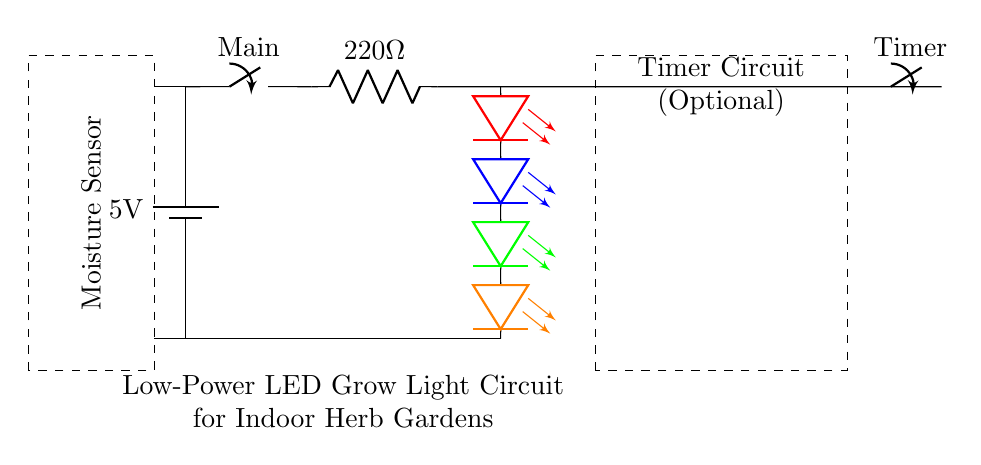What is the main power supply voltage in this circuit? The circuit uses a battery labeled with a voltage of 5V, indicating the main power supply for the circuit. This detail is crucial as it determines the voltage available for subsequent components.
Answer: 5V What is the role of the 220 Ohm resistor? The 220 Ohm resistor is a current limiting resistor, designed to restrict the flow of current to the LED array to prevent damage. By limiting the current, it ensures that the voltage drop is appropriate for the LEDs to operate safely.
Answer: Current limiting How many LEDs are in the LED array? The circuit shows a series of four LEDs of different colors (red, blue, green, orange) all connected together, indicating the total count. Each one contributes to the overall illumination of the indoor herb garden.
Answer: Four What component is used for moisture detection? The diagram features a labeled area for a moisture sensor, indicating its importance in providing feedback on the soil moisture level to optimize plant watering without over or under-watering.
Answer: Moisture sensor What is the purpose of the timer switch in the circuit? The optional timer switch allows for scheduling the operation of the LED grow lights, enabling the user to automate when the grow lights turn on or off. This can help mimic natural light patterns which are essential for healthy herb growth.
Answer: Timer switch 